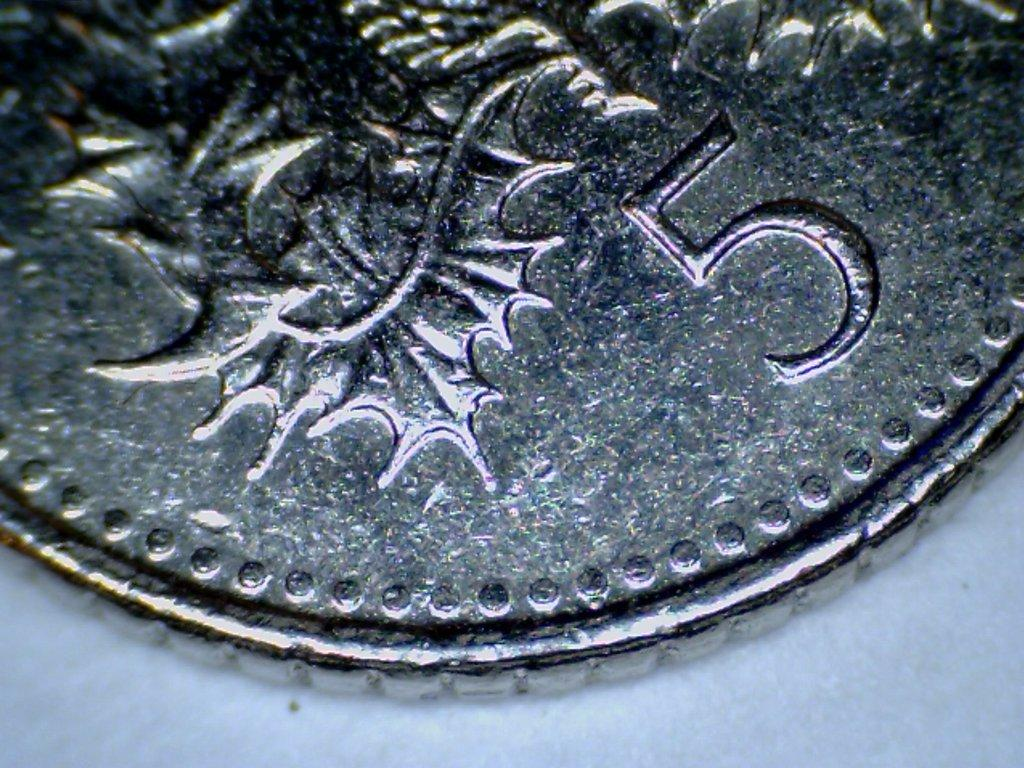What object is visible in the image? There is a coin in the image. Where is the coin located? The coin is placed on a table. How many ladybugs are crawling on the coin in the image? There are no ladybugs present in the image; it only features a coin placed on a table. 